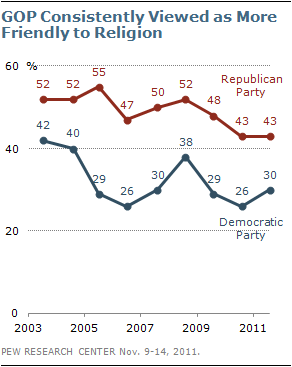Indicate a few pertinent items in this graphic. The largest gap between two lines is 26.. The line for the Republicans reached its peak in 2005. 